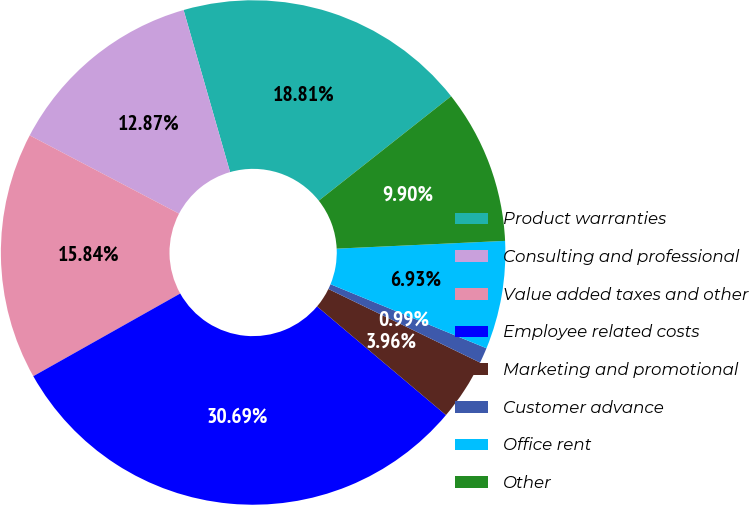<chart> <loc_0><loc_0><loc_500><loc_500><pie_chart><fcel>Product warranties<fcel>Consulting and professional<fcel>Value added taxes and other<fcel>Employee related costs<fcel>Marketing and promotional<fcel>Customer advance<fcel>Office rent<fcel>Other<nl><fcel>18.81%<fcel>12.87%<fcel>15.84%<fcel>30.69%<fcel>3.96%<fcel>0.99%<fcel>6.93%<fcel>9.9%<nl></chart> 